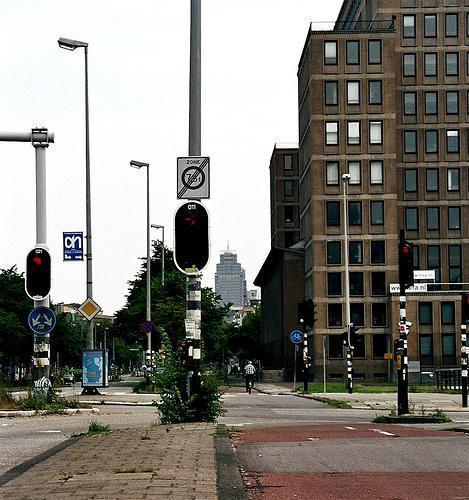How many people are visible?
Give a very brief answer. 1. 